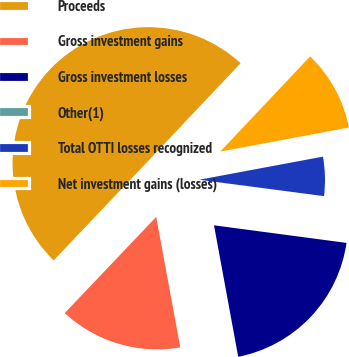Convert chart. <chart><loc_0><loc_0><loc_500><loc_500><pie_chart><fcel>Proceeds<fcel>Gross investment gains<fcel>Gross investment losses<fcel>Other(1)<fcel>Total OTTI losses recognized<fcel>Net investment gains (losses)<nl><fcel>49.95%<fcel>15.0%<fcel>20.0%<fcel>0.02%<fcel>5.02%<fcel>10.01%<nl></chart> 